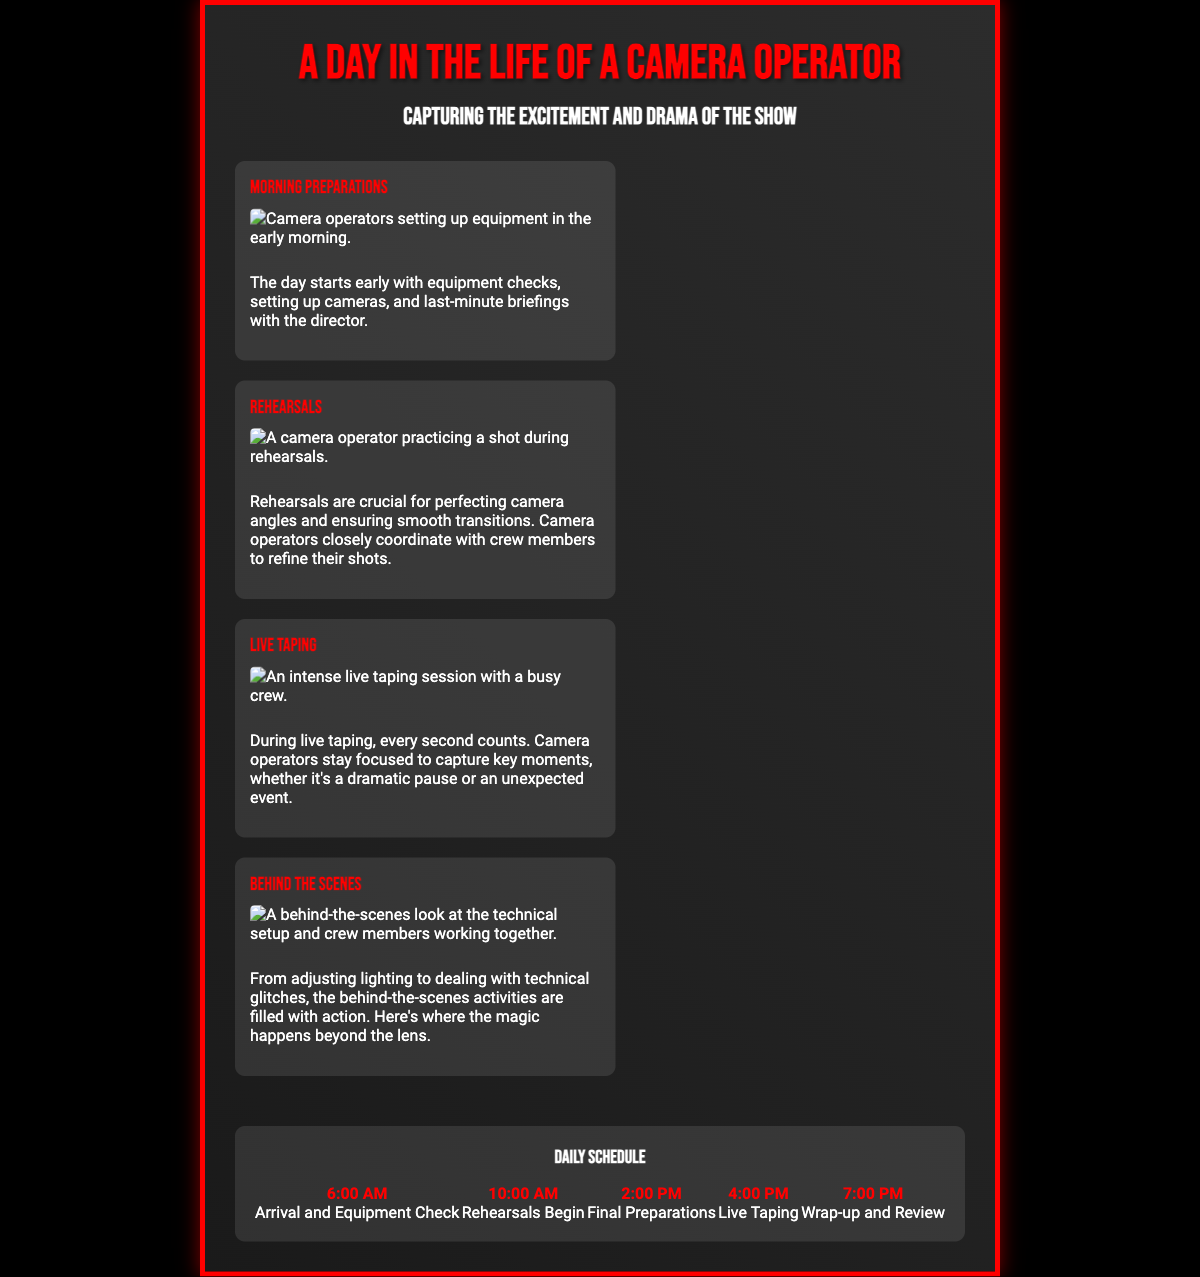What is the title of the poster? The title of the poster is prominently displayed at the top, indicating the theme of the content.
Answer: A Day in the Life of a Camera Operator What time do rehearsals begin? The timeline clearly lists the time when rehearsals start, providing a schedule for the day.
Answer: 10:00 AM What happens at 6:00 AM? The timeline item for 6:00 AM details the initial activity of the day for the camera operator.
Answer: Arrival and Equipment Check Which section includes images of the technical setup? The section that describes behind-the-scenes actions includes images of crew members and technical aspects.
Answer: Behind the Scenes What color is used for the poster's title? The title is styled with a specific color that stands out against the background, making it visually striking.
Answer: Red What is the main focus of the “Live Taping” section? The description in this section highlights the critical focus and urgency during the actual filming.
Answer: Capturing key moments How many main sections are in the poster? The number of sections is counted based on the distinct topics presented on the poster.
Answer: Four What is the last activity in the daily schedule? The timeline provides a clear sequence of activities concluding with the last entry of the day.
Answer: Wrap-up and Review Which font is used for headings? The poster's styling includes specific font choices for different textual elements.
Answer: Bebas Neue 